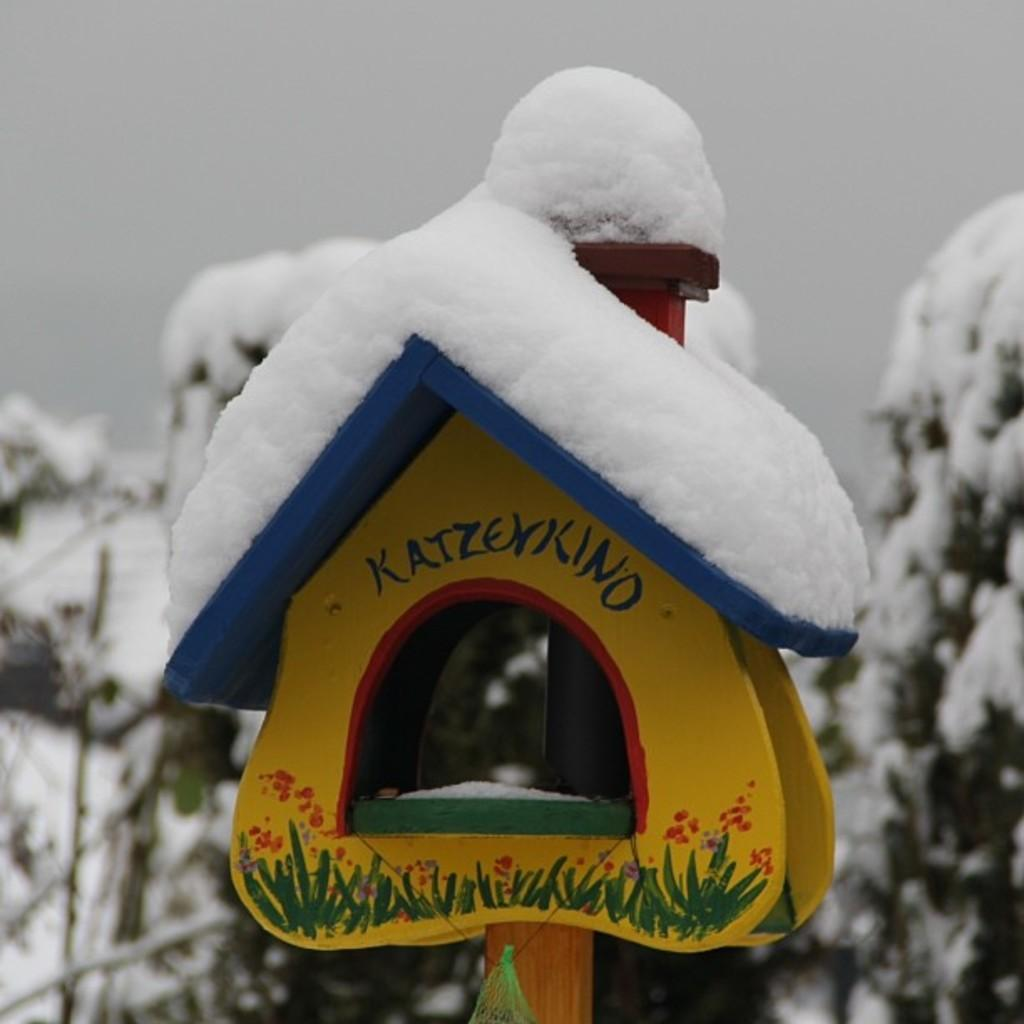What is the main subject of the image? The main subject of the image is an artificial house on a pole. What is covering the house in the image? The house has snow on it. What type of vegetation can be seen in the image? There are trees visible in the image. What is the condition of the ground in the image? There is snow on the ground. What is visible at the top of the image? The sky is visible at the top of the image. Can you tell me how many carts are parked next to the artificial house in the image? There are no carts present in the image; it features an artificial house on a pole with snow on it, trees, snow on the ground, and a visible sky. What type of ant can be seen crawling on the artificial house in the image? There are no ants present in the image; it features an artificial house on a pole with snow on it, trees, snow on the ground, and a visible sky. 